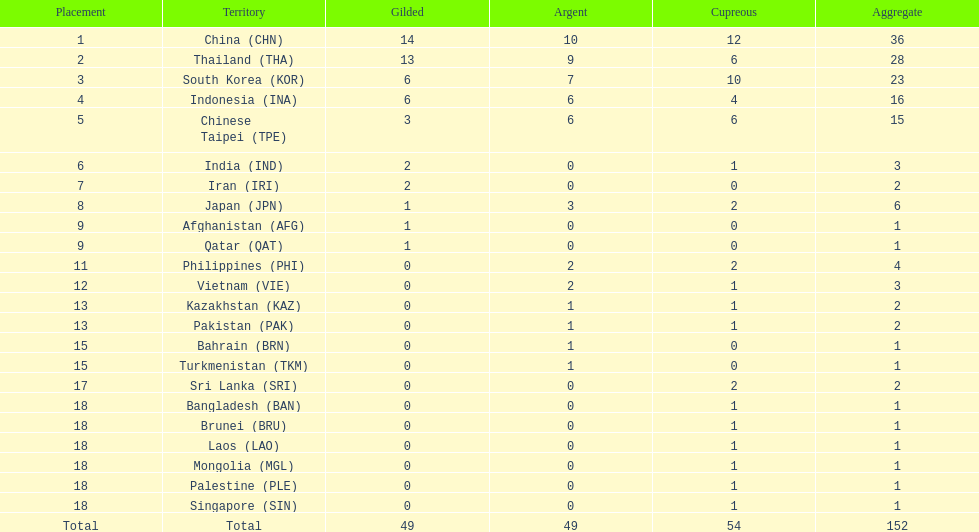How many nations received more than 5 gold medals? 4. Parse the table in full. {'header': ['Placement', 'Territory', 'Gilded', 'Argent', 'Cupreous', 'Aggregate'], 'rows': [['1', 'China\xa0(CHN)', '14', '10', '12', '36'], ['2', 'Thailand\xa0(THA)', '13', '9', '6', '28'], ['3', 'South Korea\xa0(KOR)', '6', '7', '10', '23'], ['4', 'Indonesia\xa0(INA)', '6', '6', '4', '16'], ['5', 'Chinese Taipei\xa0(TPE)', '3', '6', '6', '15'], ['6', 'India\xa0(IND)', '2', '0', '1', '3'], ['7', 'Iran\xa0(IRI)', '2', '0', '0', '2'], ['8', 'Japan\xa0(JPN)', '1', '3', '2', '6'], ['9', 'Afghanistan\xa0(AFG)', '1', '0', '0', '1'], ['9', 'Qatar\xa0(QAT)', '1', '0', '0', '1'], ['11', 'Philippines\xa0(PHI)', '0', '2', '2', '4'], ['12', 'Vietnam\xa0(VIE)', '0', '2', '1', '3'], ['13', 'Kazakhstan\xa0(KAZ)', '0', '1', '1', '2'], ['13', 'Pakistan\xa0(PAK)', '0', '1', '1', '2'], ['15', 'Bahrain\xa0(BRN)', '0', '1', '0', '1'], ['15', 'Turkmenistan\xa0(TKM)', '0', '1', '0', '1'], ['17', 'Sri Lanka\xa0(SRI)', '0', '0', '2', '2'], ['18', 'Bangladesh\xa0(BAN)', '0', '0', '1', '1'], ['18', 'Brunei\xa0(BRU)', '0', '0', '1', '1'], ['18', 'Laos\xa0(LAO)', '0', '0', '1', '1'], ['18', 'Mongolia\xa0(MGL)', '0', '0', '1', '1'], ['18', 'Palestine\xa0(PLE)', '0', '0', '1', '1'], ['18', 'Singapore\xa0(SIN)', '0', '0', '1', '1'], ['Total', 'Total', '49', '49', '54', '152']]} 